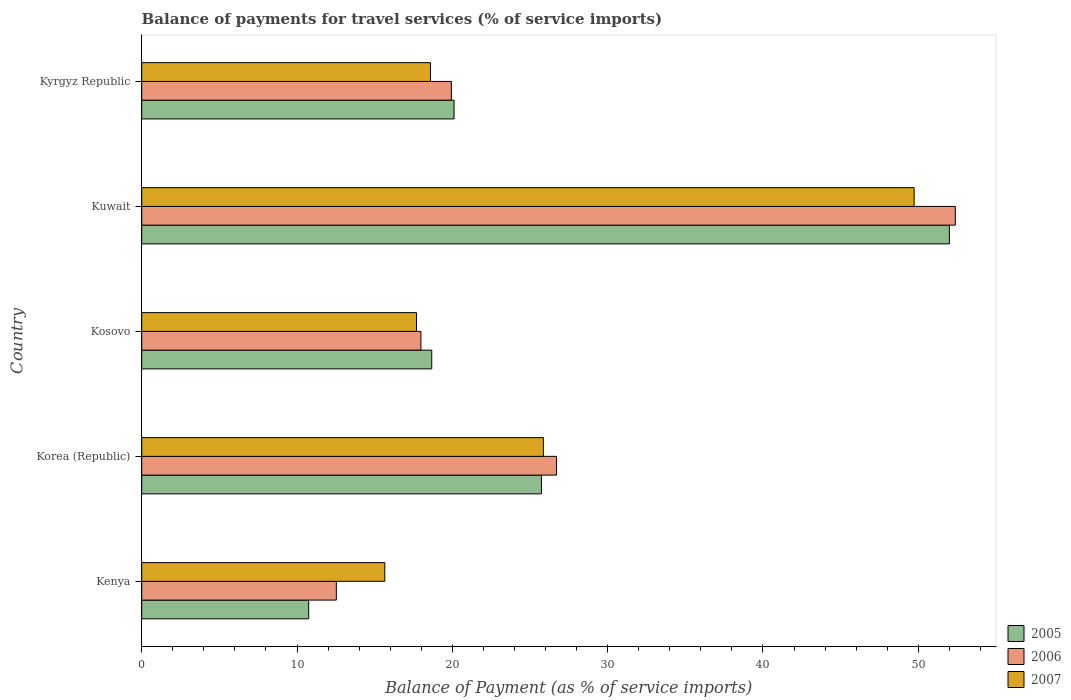How many different coloured bars are there?
Your answer should be very brief. 3. How many bars are there on the 2nd tick from the top?
Give a very brief answer. 3. How many bars are there on the 3rd tick from the bottom?
Ensure brevity in your answer.  3. What is the label of the 3rd group of bars from the top?
Your answer should be compact. Kosovo. What is the balance of payments for travel services in 2006 in Kenya?
Provide a succinct answer. 12.53. Across all countries, what is the maximum balance of payments for travel services in 2006?
Give a very brief answer. 52.38. Across all countries, what is the minimum balance of payments for travel services in 2006?
Make the answer very short. 12.53. In which country was the balance of payments for travel services in 2007 maximum?
Offer a very short reply. Kuwait. In which country was the balance of payments for travel services in 2007 minimum?
Ensure brevity in your answer.  Kenya. What is the total balance of payments for travel services in 2007 in the graph?
Offer a terse response. 127.53. What is the difference between the balance of payments for travel services in 2007 in Kosovo and that in Kuwait?
Your answer should be compact. -32.04. What is the difference between the balance of payments for travel services in 2005 in Kenya and the balance of payments for travel services in 2007 in Kyrgyz Republic?
Your answer should be very brief. -7.84. What is the average balance of payments for travel services in 2005 per country?
Give a very brief answer. 25.45. What is the difference between the balance of payments for travel services in 2007 and balance of payments for travel services in 2006 in Kosovo?
Your answer should be very brief. -0.28. In how many countries, is the balance of payments for travel services in 2007 greater than 32 %?
Provide a succinct answer. 1. What is the ratio of the balance of payments for travel services in 2007 in Kosovo to that in Kyrgyz Republic?
Make the answer very short. 0.95. Is the balance of payments for travel services in 2007 in Korea (Republic) less than that in Kosovo?
Provide a succinct answer. No. What is the difference between the highest and the second highest balance of payments for travel services in 2005?
Your response must be concise. 26.27. What is the difference between the highest and the lowest balance of payments for travel services in 2007?
Your response must be concise. 34.08. In how many countries, is the balance of payments for travel services in 2007 greater than the average balance of payments for travel services in 2007 taken over all countries?
Offer a terse response. 2. Is the sum of the balance of payments for travel services in 2005 in Kosovo and Kuwait greater than the maximum balance of payments for travel services in 2007 across all countries?
Provide a short and direct response. Yes. What does the 1st bar from the bottom in Kyrgyz Republic represents?
Provide a succinct answer. 2005. How many bars are there?
Make the answer very short. 15. What is the difference between two consecutive major ticks on the X-axis?
Keep it short and to the point. 10. Are the values on the major ticks of X-axis written in scientific E-notation?
Provide a succinct answer. No. Does the graph contain any zero values?
Give a very brief answer. No. Does the graph contain grids?
Your answer should be compact. No. What is the title of the graph?
Give a very brief answer. Balance of payments for travel services (% of service imports). What is the label or title of the X-axis?
Keep it short and to the point. Balance of Payment (as % of service imports). What is the Balance of Payment (as % of service imports) in 2005 in Kenya?
Offer a terse response. 10.75. What is the Balance of Payment (as % of service imports) in 2006 in Kenya?
Provide a succinct answer. 12.53. What is the Balance of Payment (as % of service imports) in 2007 in Kenya?
Keep it short and to the point. 15.65. What is the Balance of Payment (as % of service imports) in 2005 in Korea (Republic)?
Your answer should be compact. 25.74. What is the Balance of Payment (as % of service imports) in 2006 in Korea (Republic)?
Ensure brevity in your answer.  26.71. What is the Balance of Payment (as % of service imports) of 2007 in Korea (Republic)?
Ensure brevity in your answer.  25.86. What is the Balance of Payment (as % of service imports) in 2005 in Kosovo?
Give a very brief answer. 18.67. What is the Balance of Payment (as % of service imports) of 2006 in Kosovo?
Offer a very short reply. 17.98. What is the Balance of Payment (as % of service imports) in 2007 in Kosovo?
Your response must be concise. 17.69. What is the Balance of Payment (as % of service imports) of 2005 in Kuwait?
Ensure brevity in your answer.  52. What is the Balance of Payment (as % of service imports) in 2006 in Kuwait?
Provide a succinct answer. 52.38. What is the Balance of Payment (as % of service imports) of 2007 in Kuwait?
Offer a terse response. 49.73. What is the Balance of Payment (as % of service imports) in 2005 in Kyrgyz Republic?
Ensure brevity in your answer.  20.11. What is the Balance of Payment (as % of service imports) of 2006 in Kyrgyz Republic?
Your answer should be compact. 19.94. What is the Balance of Payment (as % of service imports) in 2007 in Kyrgyz Republic?
Offer a very short reply. 18.59. Across all countries, what is the maximum Balance of Payment (as % of service imports) of 2005?
Keep it short and to the point. 52. Across all countries, what is the maximum Balance of Payment (as % of service imports) in 2006?
Give a very brief answer. 52.38. Across all countries, what is the maximum Balance of Payment (as % of service imports) of 2007?
Offer a terse response. 49.73. Across all countries, what is the minimum Balance of Payment (as % of service imports) in 2005?
Your answer should be compact. 10.75. Across all countries, what is the minimum Balance of Payment (as % of service imports) of 2006?
Your answer should be very brief. 12.53. Across all countries, what is the minimum Balance of Payment (as % of service imports) in 2007?
Offer a terse response. 15.65. What is the total Balance of Payment (as % of service imports) of 2005 in the graph?
Keep it short and to the point. 127.27. What is the total Balance of Payment (as % of service imports) in 2006 in the graph?
Your answer should be compact. 129.53. What is the total Balance of Payment (as % of service imports) in 2007 in the graph?
Provide a short and direct response. 127.53. What is the difference between the Balance of Payment (as % of service imports) in 2005 in Kenya and that in Korea (Republic)?
Give a very brief answer. -14.99. What is the difference between the Balance of Payment (as % of service imports) of 2006 in Kenya and that in Korea (Republic)?
Provide a short and direct response. -14.18. What is the difference between the Balance of Payment (as % of service imports) of 2007 in Kenya and that in Korea (Republic)?
Ensure brevity in your answer.  -10.21. What is the difference between the Balance of Payment (as % of service imports) in 2005 in Kenya and that in Kosovo?
Offer a terse response. -7.92. What is the difference between the Balance of Payment (as % of service imports) of 2006 in Kenya and that in Kosovo?
Give a very brief answer. -5.44. What is the difference between the Balance of Payment (as % of service imports) in 2007 in Kenya and that in Kosovo?
Give a very brief answer. -2.04. What is the difference between the Balance of Payment (as % of service imports) of 2005 in Kenya and that in Kuwait?
Offer a very short reply. -41.25. What is the difference between the Balance of Payment (as % of service imports) in 2006 in Kenya and that in Kuwait?
Your answer should be very brief. -39.85. What is the difference between the Balance of Payment (as % of service imports) of 2007 in Kenya and that in Kuwait?
Give a very brief answer. -34.08. What is the difference between the Balance of Payment (as % of service imports) in 2005 in Kenya and that in Kyrgyz Republic?
Your answer should be compact. -9.36. What is the difference between the Balance of Payment (as % of service imports) in 2006 in Kenya and that in Kyrgyz Republic?
Offer a very short reply. -7.41. What is the difference between the Balance of Payment (as % of service imports) in 2007 in Kenya and that in Kyrgyz Republic?
Offer a terse response. -2.94. What is the difference between the Balance of Payment (as % of service imports) in 2005 in Korea (Republic) and that in Kosovo?
Offer a terse response. 7.06. What is the difference between the Balance of Payment (as % of service imports) of 2006 in Korea (Republic) and that in Kosovo?
Provide a succinct answer. 8.73. What is the difference between the Balance of Payment (as % of service imports) in 2007 in Korea (Republic) and that in Kosovo?
Give a very brief answer. 8.17. What is the difference between the Balance of Payment (as % of service imports) in 2005 in Korea (Republic) and that in Kuwait?
Give a very brief answer. -26.27. What is the difference between the Balance of Payment (as % of service imports) in 2006 in Korea (Republic) and that in Kuwait?
Provide a succinct answer. -25.68. What is the difference between the Balance of Payment (as % of service imports) in 2007 in Korea (Republic) and that in Kuwait?
Offer a very short reply. -23.87. What is the difference between the Balance of Payment (as % of service imports) in 2005 in Korea (Republic) and that in Kyrgyz Republic?
Provide a short and direct response. 5.63. What is the difference between the Balance of Payment (as % of service imports) in 2006 in Korea (Republic) and that in Kyrgyz Republic?
Ensure brevity in your answer.  6.77. What is the difference between the Balance of Payment (as % of service imports) in 2007 in Korea (Republic) and that in Kyrgyz Republic?
Ensure brevity in your answer.  7.27. What is the difference between the Balance of Payment (as % of service imports) in 2005 in Kosovo and that in Kuwait?
Offer a very short reply. -33.33. What is the difference between the Balance of Payment (as % of service imports) of 2006 in Kosovo and that in Kuwait?
Offer a terse response. -34.41. What is the difference between the Balance of Payment (as % of service imports) in 2007 in Kosovo and that in Kuwait?
Offer a very short reply. -32.04. What is the difference between the Balance of Payment (as % of service imports) in 2005 in Kosovo and that in Kyrgyz Republic?
Keep it short and to the point. -1.44. What is the difference between the Balance of Payment (as % of service imports) in 2006 in Kosovo and that in Kyrgyz Republic?
Make the answer very short. -1.96. What is the difference between the Balance of Payment (as % of service imports) in 2007 in Kosovo and that in Kyrgyz Republic?
Your response must be concise. -0.9. What is the difference between the Balance of Payment (as % of service imports) of 2005 in Kuwait and that in Kyrgyz Republic?
Offer a terse response. 31.89. What is the difference between the Balance of Payment (as % of service imports) in 2006 in Kuwait and that in Kyrgyz Republic?
Your response must be concise. 32.45. What is the difference between the Balance of Payment (as % of service imports) in 2007 in Kuwait and that in Kyrgyz Republic?
Keep it short and to the point. 31.14. What is the difference between the Balance of Payment (as % of service imports) in 2005 in Kenya and the Balance of Payment (as % of service imports) in 2006 in Korea (Republic)?
Offer a terse response. -15.96. What is the difference between the Balance of Payment (as % of service imports) of 2005 in Kenya and the Balance of Payment (as % of service imports) of 2007 in Korea (Republic)?
Your response must be concise. -15.11. What is the difference between the Balance of Payment (as % of service imports) of 2006 in Kenya and the Balance of Payment (as % of service imports) of 2007 in Korea (Republic)?
Your answer should be compact. -13.33. What is the difference between the Balance of Payment (as % of service imports) of 2005 in Kenya and the Balance of Payment (as % of service imports) of 2006 in Kosovo?
Ensure brevity in your answer.  -7.23. What is the difference between the Balance of Payment (as % of service imports) in 2005 in Kenya and the Balance of Payment (as % of service imports) in 2007 in Kosovo?
Give a very brief answer. -6.94. What is the difference between the Balance of Payment (as % of service imports) of 2006 in Kenya and the Balance of Payment (as % of service imports) of 2007 in Kosovo?
Provide a succinct answer. -5.16. What is the difference between the Balance of Payment (as % of service imports) of 2005 in Kenya and the Balance of Payment (as % of service imports) of 2006 in Kuwait?
Your answer should be very brief. -41.63. What is the difference between the Balance of Payment (as % of service imports) in 2005 in Kenya and the Balance of Payment (as % of service imports) in 2007 in Kuwait?
Your answer should be very brief. -38.98. What is the difference between the Balance of Payment (as % of service imports) in 2006 in Kenya and the Balance of Payment (as % of service imports) in 2007 in Kuwait?
Your response must be concise. -37.2. What is the difference between the Balance of Payment (as % of service imports) in 2005 in Kenya and the Balance of Payment (as % of service imports) in 2006 in Kyrgyz Republic?
Keep it short and to the point. -9.19. What is the difference between the Balance of Payment (as % of service imports) of 2005 in Kenya and the Balance of Payment (as % of service imports) of 2007 in Kyrgyz Republic?
Provide a short and direct response. -7.84. What is the difference between the Balance of Payment (as % of service imports) in 2006 in Kenya and the Balance of Payment (as % of service imports) in 2007 in Kyrgyz Republic?
Keep it short and to the point. -6.06. What is the difference between the Balance of Payment (as % of service imports) of 2005 in Korea (Republic) and the Balance of Payment (as % of service imports) of 2006 in Kosovo?
Your response must be concise. 7.76. What is the difference between the Balance of Payment (as % of service imports) in 2005 in Korea (Republic) and the Balance of Payment (as % of service imports) in 2007 in Kosovo?
Your answer should be compact. 8.04. What is the difference between the Balance of Payment (as % of service imports) of 2006 in Korea (Republic) and the Balance of Payment (as % of service imports) of 2007 in Kosovo?
Keep it short and to the point. 9.02. What is the difference between the Balance of Payment (as % of service imports) of 2005 in Korea (Republic) and the Balance of Payment (as % of service imports) of 2006 in Kuwait?
Offer a terse response. -26.65. What is the difference between the Balance of Payment (as % of service imports) in 2005 in Korea (Republic) and the Balance of Payment (as % of service imports) in 2007 in Kuwait?
Provide a short and direct response. -24. What is the difference between the Balance of Payment (as % of service imports) of 2006 in Korea (Republic) and the Balance of Payment (as % of service imports) of 2007 in Kuwait?
Offer a terse response. -23.02. What is the difference between the Balance of Payment (as % of service imports) in 2005 in Korea (Republic) and the Balance of Payment (as % of service imports) in 2006 in Kyrgyz Republic?
Provide a short and direct response. 5.8. What is the difference between the Balance of Payment (as % of service imports) of 2005 in Korea (Republic) and the Balance of Payment (as % of service imports) of 2007 in Kyrgyz Republic?
Keep it short and to the point. 7.15. What is the difference between the Balance of Payment (as % of service imports) of 2006 in Korea (Republic) and the Balance of Payment (as % of service imports) of 2007 in Kyrgyz Republic?
Offer a very short reply. 8.12. What is the difference between the Balance of Payment (as % of service imports) of 2005 in Kosovo and the Balance of Payment (as % of service imports) of 2006 in Kuwait?
Ensure brevity in your answer.  -33.71. What is the difference between the Balance of Payment (as % of service imports) in 2005 in Kosovo and the Balance of Payment (as % of service imports) in 2007 in Kuwait?
Make the answer very short. -31.06. What is the difference between the Balance of Payment (as % of service imports) of 2006 in Kosovo and the Balance of Payment (as % of service imports) of 2007 in Kuwait?
Make the answer very short. -31.76. What is the difference between the Balance of Payment (as % of service imports) of 2005 in Kosovo and the Balance of Payment (as % of service imports) of 2006 in Kyrgyz Republic?
Offer a very short reply. -1.26. What is the difference between the Balance of Payment (as % of service imports) in 2005 in Kosovo and the Balance of Payment (as % of service imports) in 2007 in Kyrgyz Republic?
Your response must be concise. 0.08. What is the difference between the Balance of Payment (as % of service imports) in 2006 in Kosovo and the Balance of Payment (as % of service imports) in 2007 in Kyrgyz Republic?
Your response must be concise. -0.62. What is the difference between the Balance of Payment (as % of service imports) in 2005 in Kuwait and the Balance of Payment (as % of service imports) in 2006 in Kyrgyz Republic?
Give a very brief answer. 32.07. What is the difference between the Balance of Payment (as % of service imports) of 2005 in Kuwait and the Balance of Payment (as % of service imports) of 2007 in Kyrgyz Republic?
Your answer should be compact. 33.41. What is the difference between the Balance of Payment (as % of service imports) in 2006 in Kuwait and the Balance of Payment (as % of service imports) in 2007 in Kyrgyz Republic?
Provide a succinct answer. 33.79. What is the average Balance of Payment (as % of service imports) in 2005 per country?
Your answer should be very brief. 25.45. What is the average Balance of Payment (as % of service imports) of 2006 per country?
Offer a terse response. 25.91. What is the average Balance of Payment (as % of service imports) in 2007 per country?
Make the answer very short. 25.51. What is the difference between the Balance of Payment (as % of service imports) in 2005 and Balance of Payment (as % of service imports) in 2006 in Kenya?
Make the answer very short. -1.78. What is the difference between the Balance of Payment (as % of service imports) of 2005 and Balance of Payment (as % of service imports) of 2007 in Kenya?
Provide a succinct answer. -4.9. What is the difference between the Balance of Payment (as % of service imports) in 2006 and Balance of Payment (as % of service imports) in 2007 in Kenya?
Ensure brevity in your answer.  -3.12. What is the difference between the Balance of Payment (as % of service imports) in 2005 and Balance of Payment (as % of service imports) in 2006 in Korea (Republic)?
Keep it short and to the point. -0.97. What is the difference between the Balance of Payment (as % of service imports) in 2005 and Balance of Payment (as % of service imports) in 2007 in Korea (Republic)?
Offer a very short reply. -0.13. What is the difference between the Balance of Payment (as % of service imports) in 2006 and Balance of Payment (as % of service imports) in 2007 in Korea (Republic)?
Your answer should be compact. 0.84. What is the difference between the Balance of Payment (as % of service imports) in 2005 and Balance of Payment (as % of service imports) in 2006 in Kosovo?
Provide a short and direct response. 0.7. What is the difference between the Balance of Payment (as % of service imports) in 2005 and Balance of Payment (as % of service imports) in 2007 in Kosovo?
Your answer should be compact. 0.98. What is the difference between the Balance of Payment (as % of service imports) in 2006 and Balance of Payment (as % of service imports) in 2007 in Kosovo?
Your answer should be very brief. 0.28. What is the difference between the Balance of Payment (as % of service imports) of 2005 and Balance of Payment (as % of service imports) of 2006 in Kuwait?
Provide a succinct answer. -0.38. What is the difference between the Balance of Payment (as % of service imports) in 2005 and Balance of Payment (as % of service imports) in 2007 in Kuwait?
Ensure brevity in your answer.  2.27. What is the difference between the Balance of Payment (as % of service imports) of 2006 and Balance of Payment (as % of service imports) of 2007 in Kuwait?
Provide a short and direct response. 2.65. What is the difference between the Balance of Payment (as % of service imports) in 2005 and Balance of Payment (as % of service imports) in 2006 in Kyrgyz Republic?
Provide a succinct answer. 0.17. What is the difference between the Balance of Payment (as % of service imports) of 2005 and Balance of Payment (as % of service imports) of 2007 in Kyrgyz Republic?
Provide a short and direct response. 1.52. What is the difference between the Balance of Payment (as % of service imports) in 2006 and Balance of Payment (as % of service imports) in 2007 in Kyrgyz Republic?
Your answer should be very brief. 1.35. What is the ratio of the Balance of Payment (as % of service imports) of 2005 in Kenya to that in Korea (Republic)?
Make the answer very short. 0.42. What is the ratio of the Balance of Payment (as % of service imports) in 2006 in Kenya to that in Korea (Republic)?
Your answer should be very brief. 0.47. What is the ratio of the Balance of Payment (as % of service imports) in 2007 in Kenya to that in Korea (Republic)?
Offer a very short reply. 0.61. What is the ratio of the Balance of Payment (as % of service imports) in 2005 in Kenya to that in Kosovo?
Your response must be concise. 0.58. What is the ratio of the Balance of Payment (as % of service imports) in 2006 in Kenya to that in Kosovo?
Give a very brief answer. 0.7. What is the ratio of the Balance of Payment (as % of service imports) of 2007 in Kenya to that in Kosovo?
Provide a short and direct response. 0.88. What is the ratio of the Balance of Payment (as % of service imports) of 2005 in Kenya to that in Kuwait?
Your answer should be compact. 0.21. What is the ratio of the Balance of Payment (as % of service imports) in 2006 in Kenya to that in Kuwait?
Your answer should be compact. 0.24. What is the ratio of the Balance of Payment (as % of service imports) of 2007 in Kenya to that in Kuwait?
Ensure brevity in your answer.  0.31. What is the ratio of the Balance of Payment (as % of service imports) of 2005 in Kenya to that in Kyrgyz Republic?
Keep it short and to the point. 0.53. What is the ratio of the Balance of Payment (as % of service imports) of 2006 in Kenya to that in Kyrgyz Republic?
Make the answer very short. 0.63. What is the ratio of the Balance of Payment (as % of service imports) of 2007 in Kenya to that in Kyrgyz Republic?
Your answer should be very brief. 0.84. What is the ratio of the Balance of Payment (as % of service imports) of 2005 in Korea (Republic) to that in Kosovo?
Offer a terse response. 1.38. What is the ratio of the Balance of Payment (as % of service imports) in 2006 in Korea (Republic) to that in Kosovo?
Provide a short and direct response. 1.49. What is the ratio of the Balance of Payment (as % of service imports) of 2007 in Korea (Republic) to that in Kosovo?
Your answer should be compact. 1.46. What is the ratio of the Balance of Payment (as % of service imports) of 2005 in Korea (Republic) to that in Kuwait?
Keep it short and to the point. 0.49. What is the ratio of the Balance of Payment (as % of service imports) in 2006 in Korea (Republic) to that in Kuwait?
Your response must be concise. 0.51. What is the ratio of the Balance of Payment (as % of service imports) in 2007 in Korea (Republic) to that in Kuwait?
Your answer should be compact. 0.52. What is the ratio of the Balance of Payment (as % of service imports) in 2005 in Korea (Republic) to that in Kyrgyz Republic?
Keep it short and to the point. 1.28. What is the ratio of the Balance of Payment (as % of service imports) in 2006 in Korea (Republic) to that in Kyrgyz Republic?
Your response must be concise. 1.34. What is the ratio of the Balance of Payment (as % of service imports) in 2007 in Korea (Republic) to that in Kyrgyz Republic?
Your answer should be very brief. 1.39. What is the ratio of the Balance of Payment (as % of service imports) in 2005 in Kosovo to that in Kuwait?
Ensure brevity in your answer.  0.36. What is the ratio of the Balance of Payment (as % of service imports) of 2006 in Kosovo to that in Kuwait?
Offer a terse response. 0.34. What is the ratio of the Balance of Payment (as % of service imports) in 2007 in Kosovo to that in Kuwait?
Keep it short and to the point. 0.36. What is the ratio of the Balance of Payment (as % of service imports) of 2005 in Kosovo to that in Kyrgyz Republic?
Your answer should be compact. 0.93. What is the ratio of the Balance of Payment (as % of service imports) in 2006 in Kosovo to that in Kyrgyz Republic?
Your response must be concise. 0.9. What is the ratio of the Balance of Payment (as % of service imports) of 2007 in Kosovo to that in Kyrgyz Republic?
Give a very brief answer. 0.95. What is the ratio of the Balance of Payment (as % of service imports) in 2005 in Kuwait to that in Kyrgyz Republic?
Make the answer very short. 2.59. What is the ratio of the Balance of Payment (as % of service imports) in 2006 in Kuwait to that in Kyrgyz Republic?
Give a very brief answer. 2.63. What is the ratio of the Balance of Payment (as % of service imports) in 2007 in Kuwait to that in Kyrgyz Republic?
Your answer should be very brief. 2.68. What is the difference between the highest and the second highest Balance of Payment (as % of service imports) of 2005?
Make the answer very short. 26.27. What is the difference between the highest and the second highest Balance of Payment (as % of service imports) in 2006?
Keep it short and to the point. 25.68. What is the difference between the highest and the second highest Balance of Payment (as % of service imports) in 2007?
Ensure brevity in your answer.  23.87. What is the difference between the highest and the lowest Balance of Payment (as % of service imports) in 2005?
Give a very brief answer. 41.25. What is the difference between the highest and the lowest Balance of Payment (as % of service imports) in 2006?
Offer a terse response. 39.85. What is the difference between the highest and the lowest Balance of Payment (as % of service imports) in 2007?
Your response must be concise. 34.08. 